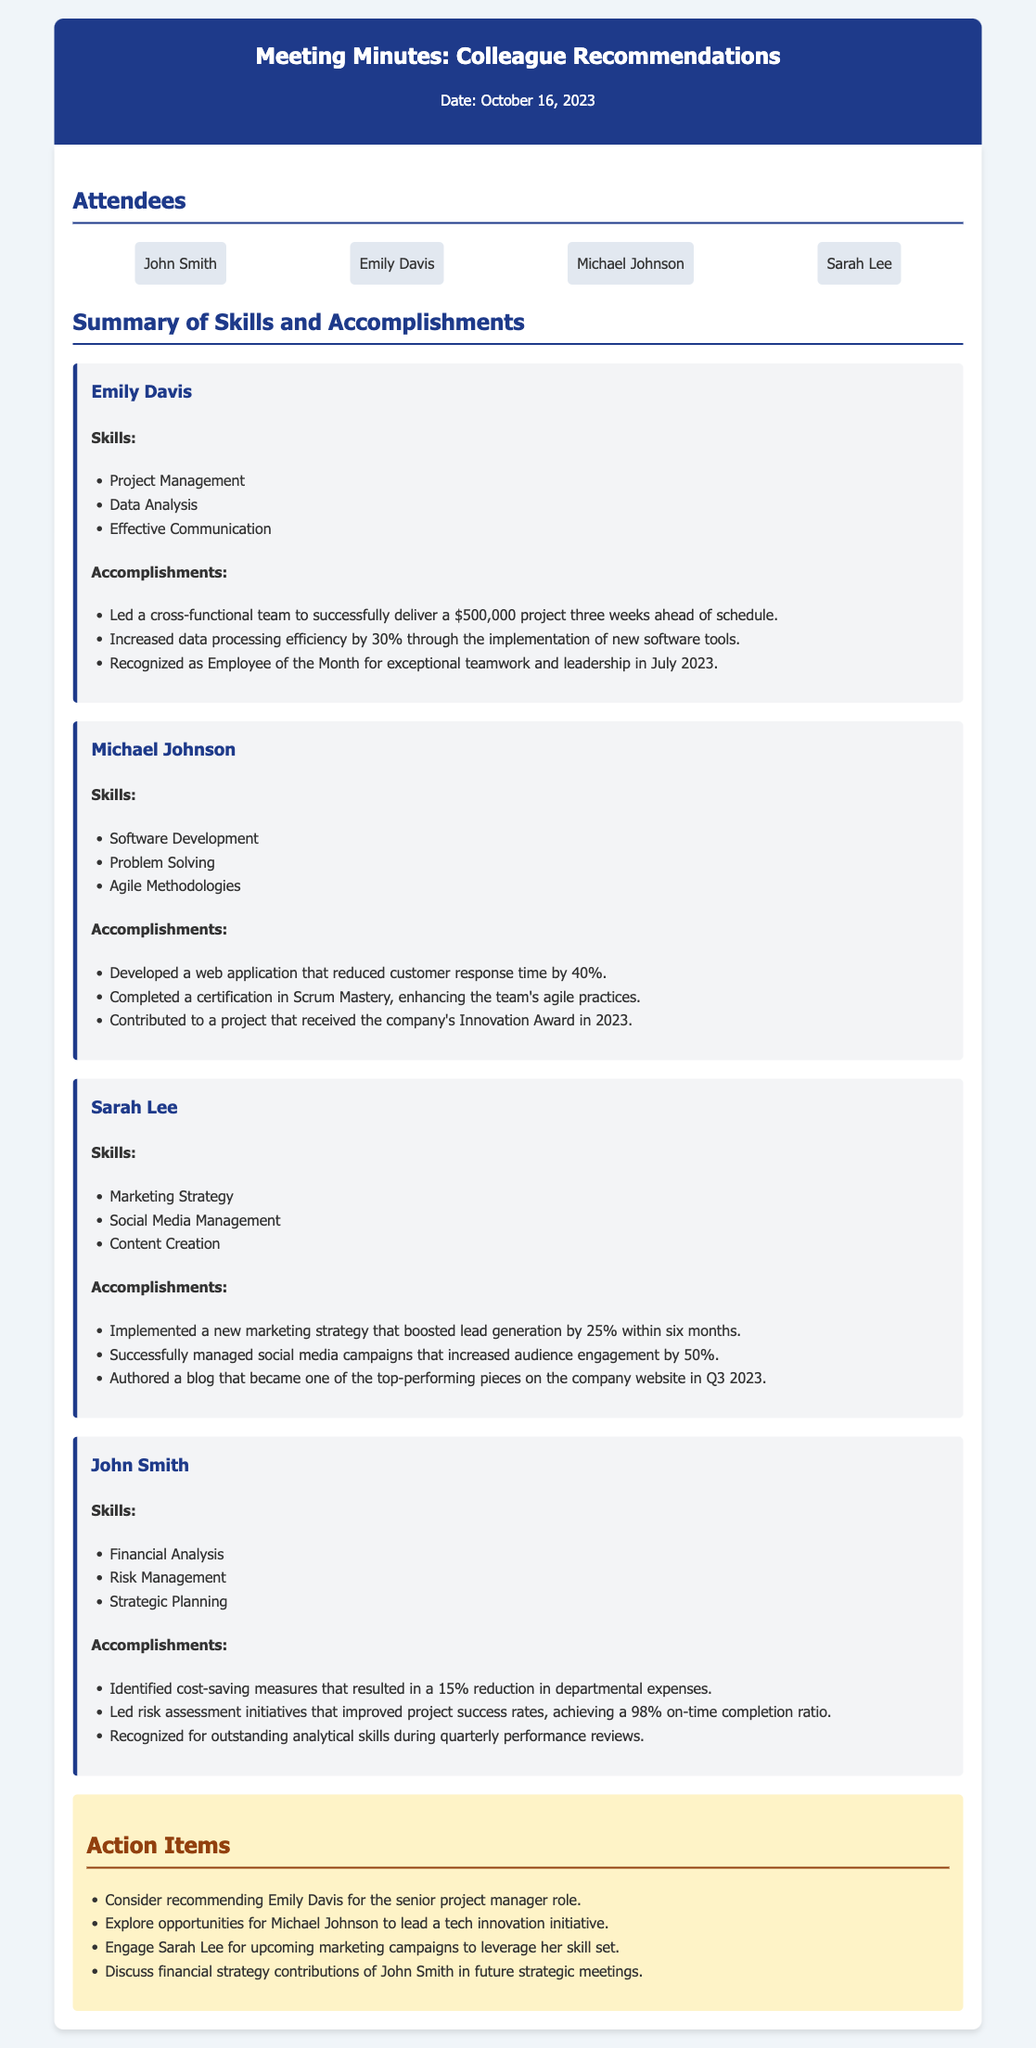What is the date of the meeting? The date of the meeting is explicitly mentioned in the header of the document.
Answer: October 16, 2023 Who is recognized as Employee of the Month? This information is found under the accomplishments of Emily Davis.
Answer: Emily Davis What project did Emily Davis lead? The specific project led by Emily Davis is mentioned along with its budget and completion details.
Answer: $500,000 project How much did Michael Johnson reduce customer response time? This figure is detailed in Michael Johnson's accomplishments.
Answer: 40% Which colleague's marketing strategy boosted lead generation by what percentage? This information combines Sarah Lee's skills and accomplishments, requiring synthesis to answer accurately.
Answer: Sarah Lee, 25% What action item involves John Smith? The action items section provides clear details about future discussions regarding John Smith's contributions.
Answer: Discuss financial strategy contributions What skills are listed for Sarah Lee? The skills for Sarah Lee are specifically outlined in her section of the document.
Answer: Marketing Strategy, Social Media Management, Content Creation How many skills are listed under Michael Johnson? A count of the skills listed under Michael Johnson can be calculated from the document.
Answer: Three What award did a project associated with Michael Johnson receive? This is mentioned in the accomplishments section related to Michael Johnson's contributions.
Answer: Innovation Award 